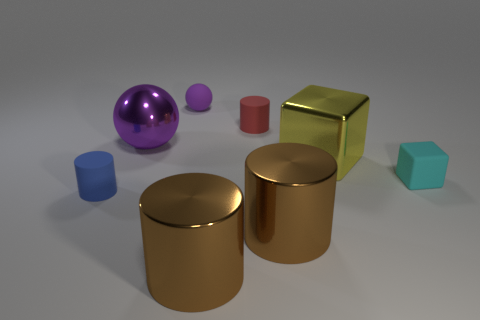Add 1 red rubber cubes. How many objects exist? 9 Subtract all small blue matte cylinders. How many cylinders are left? 3 Add 1 matte cubes. How many matte cubes are left? 2 Add 1 tiny red matte cylinders. How many tiny red matte cylinders exist? 2 Subtract all yellow blocks. How many blocks are left? 1 Subtract 1 blue cylinders. How many objects are left? 7 Subtract all blocks. How many objects are left? 6 Subtract 3 cylinders. How many cylinders are left? 1 Subtract all yellow cylinders. Subtract all gray spheres. How many cylinders are left? 4 Subtract all green cylinders. How many cyan balls are left? 0 